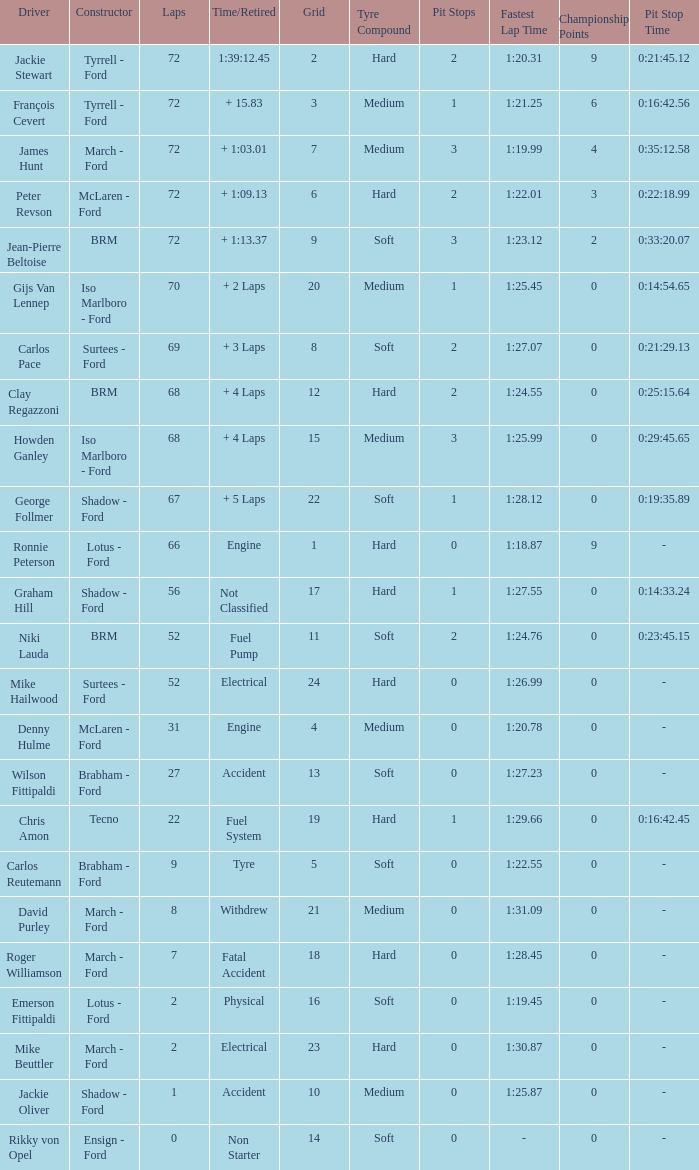What is the top lap that had a tyre time? 9.0. 